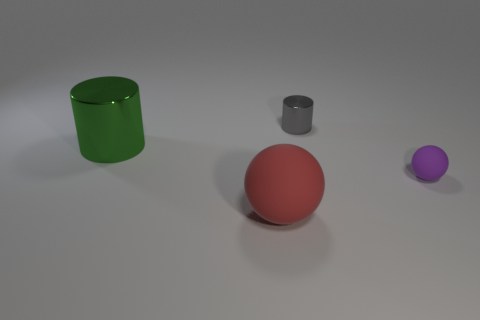Are there more objects in front of the green metallic cylinder than objects that are left of the tiny purple ball?
Ensure brevity in your answer.  No. What material is the red thing that is the same shape as the purple thing?
Offer a terse response. Rubber. What is the shape of the gray metallic object?
Provide a succinct answer. Cylinder. Are there more tiny things behind the green cylinder than cyan blocks?
Ensure brevity in your answer.  Yes. There is a large object that is to the left of the red matte thing; what shape is it?
Keep it short and to the point. Cylinder. How many other things are there of the same shape as the purple thing?
Offer a terse response. 1. Are the cylinder to the left of the tiny gray cylinder and the small cylinder made of the same material?
Give a very brief answer. Yes. Are there an equal number of big rubber objects that are right of the big red ball and tiny gray metallic things behind the tiny purple rubber ball?
Offer a terse response. No. There is a rubber object that is to the right of the large red object; what is its size?
Your response must be concise. Small. Is there a purple thing made of the same material as the red object?
Make the answer very short. Yes. 